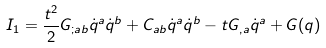<formula> <loc_0><loc_0><loc_500><loc_500>I _ { 1 } = \frac { t ^ { 2 } } { 2 } G _ { ; a b } \dot { q } ^ { a } \dot { q } ^ { b } + C _ { a b } \dot { q } ^ { a } \dot { q } ^ { b } - t G _ { , a } \dot { q } ^ { a } + G ( q )</formula> 